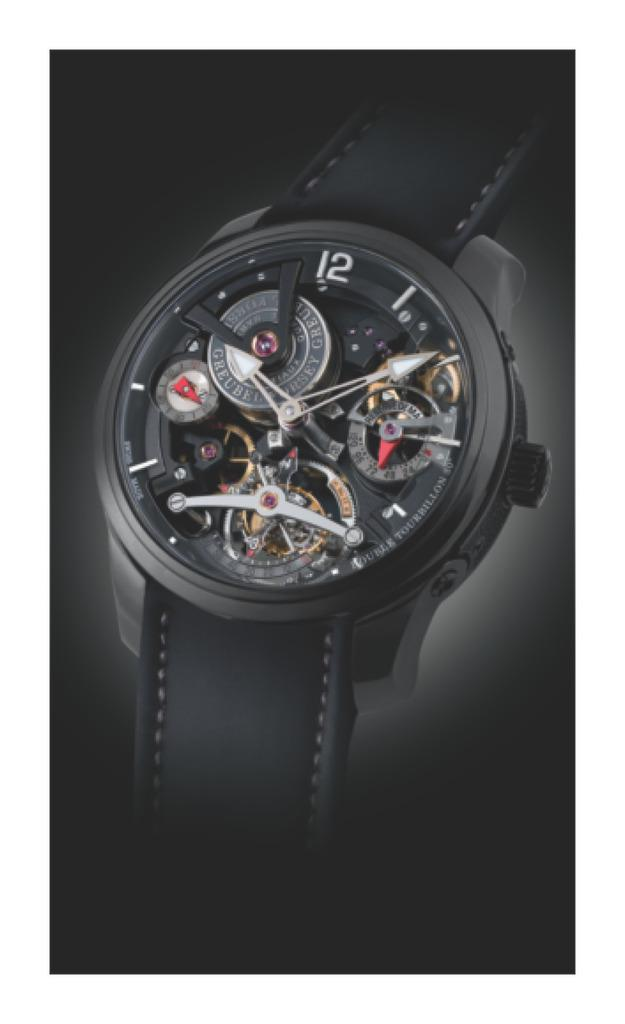Provide a one-sentence caption for the provided image. black watch that shows the inner workings and has number 12 at top. 